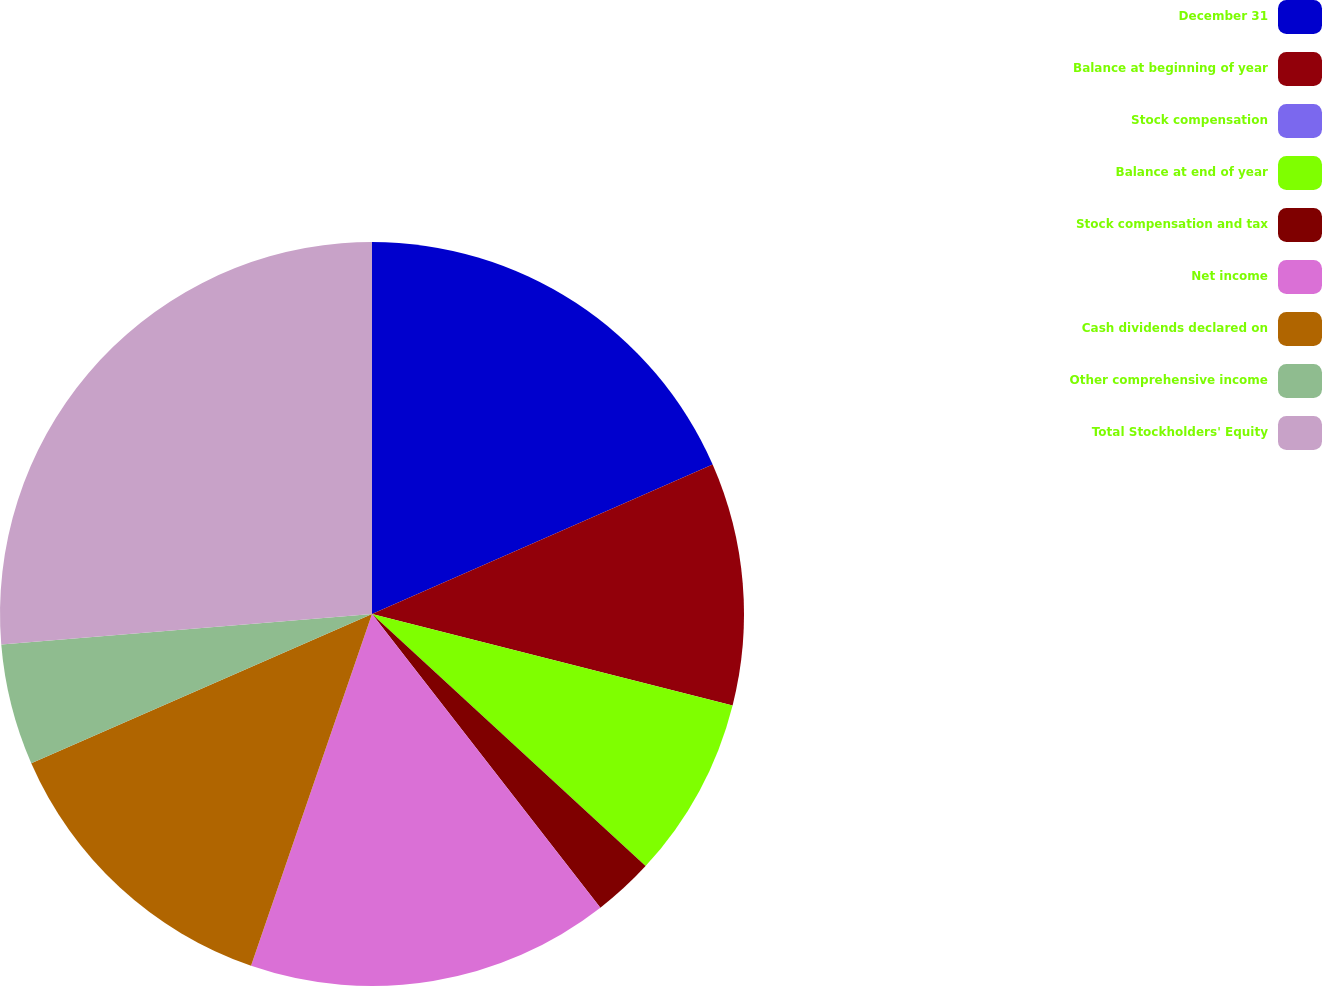Convert chart to OTSL. <chart><loc_0><loc_0><loc_500><loc_500><pie_chart><fcel>December 31<fcel>Balance at beginning of year<fcel>Stock compensation<fcel>Balance at end of year<fcel>Stock compensation and tax<fcel>Net income<fcel>Cash dividends declared on<fcel>Other comprehensive income<fcel>Total Stockholders' Equity<nl><fcel>18.42%<fcel>10.53%<fcel>0.0%<fcel>7.9%<fcel>2.63%<fcel>15.79%<fcel>13.16%<fcel>5.26%<fcel>26.31%<nl></chart> 